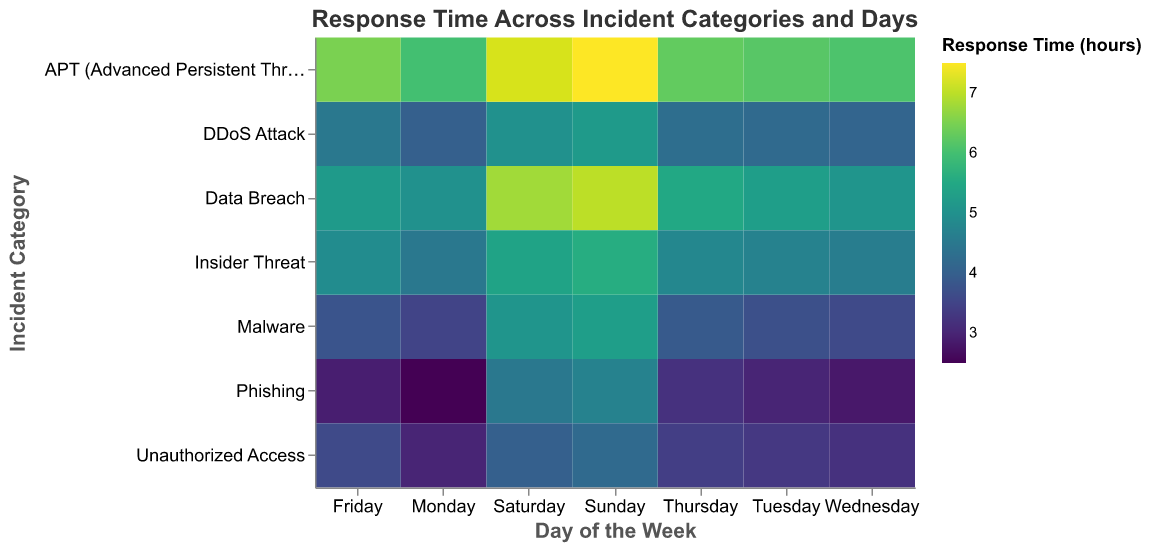What is the average response time for Phishing incidents on weekdays? To find the average response time for Phishing incidents on weekdays (Monday to Friday), sum the response times for these days and then divide by the number of days. The times are 2.5, 3.0, 2.8, 3.2, and 2.9. Sum = 2.5 + 3.0 + 2.8 + 3.2 + 2.9 = 14.4. Average = 14.4 / 5 = 2.88
Answer: 2.88 hours Which incident category has the highest response time on Sunday? Look at the response times for all incident categories on Sunday. The values are: Phishing (4.7), Malware (5.3), Data Breach (7.0), DDoS Attack (5.2), Insider Threat (5.6), Unauthorized Access (4.2), APT (7.5). The highest value is 7.5, corresponding to APT.
Answer: APT How does the response time for Malware incidents compare between Monday and Wednesday? Compare the response times for Malware on Monday and Wednesday. Monday is 3.5 and Wednesday is 3.6.
Answer: Wednesday is higher by 0.1 hours On which day is the response time for Data Breach incidents lowest? Look at the response times for Data Breach incidents across all days of the week. The values are: Monday (5.0), Tuesday (5.3), Wednesday (5.1), Thursday (5.5), Friday (5.2), Saturday (6.8), Sunday (7.0). The lowest value is 5.0 on Monday.
Answer: Monday What is the total response time for DDoS Attack incidents during the weekend? Sum the response times for DDoS Attack incidents on Saturday and Sunday. The values are 5.0 (Saturday) and 5.2 (Sunday). Sum = 5.0 + 5.2 = 10.2
Answer: 10.2 hours Which incident category shows the greatest increase in response time from Thursday to Friday? Calculate the difference in response times from Thursday to Friday for each incident category: 
Phishing (3.2 to 2.9, -0.3), 
Malware (3.9 to 3.8, -0.1), 
Data Breach (5.5 to 5.2, -0.3), 
DDoS Attack (4.3 to 4.5, +0.2), 
Insider Threat (4.8 to 4.9, +0.1), 
Unauthorized Access (3.4 to 3.6, +0.2), 
APT (6.3 to 6.5, +0.2). 
The greatest increase is in APT (0.2).
Answer: DDoS Attack, Unauthorized Access, APT What is the range of response times for Insider Threat incidents on weekdays? Identify the maximum and minimum response times for Insider Threat from Monday to Friday: {4.5, 4.7, 4.6, 4.8, 4.9}. The minimum is 4.5 and the maximum is 4.9. Range = 4.9 - 4.5 = 0.4
Answer: 0.4 hours Which day has the highest overall average response time across all incident categories? Find the average response time for each day by summing the response times for all incident categories on that day and dividing by the number of categories. For Sunday: (4.7 + 5.3 + 7.0 + 5.2 + 5.6 + 4.2 + 7.5) / 7 = 39.5 / 7 ≈ 5.64. Repeat for other days. The highest average is on Sunday.
Answer: Sunday 